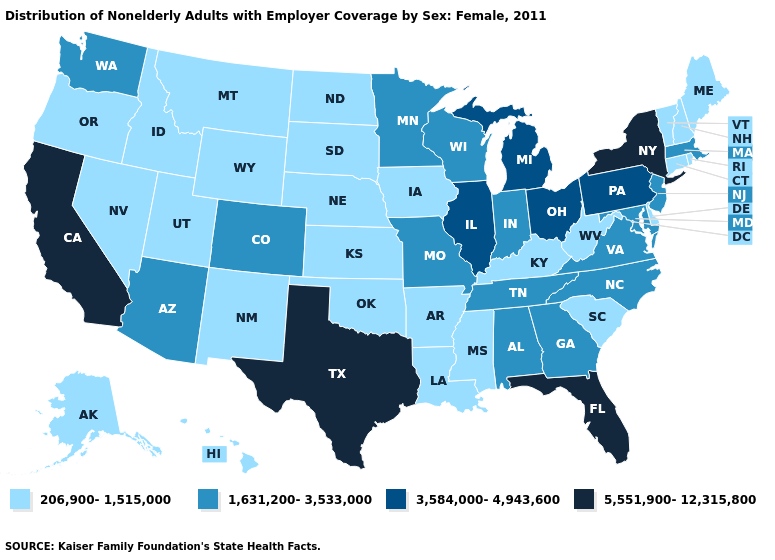How many symbols are there in the legend?
Short answer required. 4. Name the states that have a value in the range 1,631,200-3,533,000?
Concise answer only. Alabama, Arizona, Colorado, Georgia, Indiana, Maryland, Massachusetts, Minnesota, Missouri, New Jersey, North Carolina, Tennessee, Virginia, Washington, Wisconsin. Which states hav the highest value in the MidWest?
Write a very short answer. Illinois, Michigan, Ohio. Which states have the lowest value in the USA?
Write a very short answer. Alaska, Arkansas, Connecticut, Delaware, Hawaii, Idaho, Iowa, Kansas, Kentucky, Louisiana, Maine, Mississippi, Montana, Nebraska, Nevada, New Hampshire, New Mexico, North Dakota, Oklahoma, Oregon, Rhode Island, South Carolina, South Dakota, Utah, Vermont, West Virginia, Wyoming. Among the states that border South Dakota , which have the lowest value?
Give a very brief answer. Iowa, Montana, Nebraska, North Dakota, Wyoming. Name the states that have a value in the range 1,631,200-3,533,000?
Keep it brief. Alabama, Arizona, Colorado, Georgia, Indiana, Maryland, Massachusetts, Minnesota, Missouri, New Jersey, North Carolina, Tennessee, Virginia, Washington, Wisconsin. Name the states that have a value in the range 5,551,900-12,315,800?
Write a very short answer. California, Florida, New York, Texas. What is the highest value in the Northeast ?
Give a very brief answer. 5,551,900-12,315,800. What is the value of California?
Short answer required. 5,551,900-12,315,800. Among the states that border Connecticut , does New York have the highest value?
Keep it brief. Yes. What is the lowest value in the USA?
Keep it brief. 206,900-1,515,000. Name the states that have a value in the range 1,631,200-3,533,000?
Answer briefly. Alabama, Arizona, Colorado, Georgia, Indiana, Maryland, Massachusetts, Minnesota, Missouri, New Jersey, North Carolina, Tennessee, Virginia, Washington, Wisconsin. Does Maine have the same value as Maryland?
Answer briefly. No. Which states have the lowest value in the USA?
Concise answer only. Alaska, Arkansas, Connecticut, Delaware, Hawaii, Idaho, Iowa, Kansas, Kentucky, Louisiana, Maine, Mississippi, Montana, Nebraska, Nevada, New Hampshire, New Mexico, North Dakota, Oklahoma, Oregon, Rhode Island, South Carolina, South Dakota, Utah, Vermont, West Virginia, Wyoming. Among the states that border New Jersey , does New York have the highest value?
Write a very short answer. Yes. 